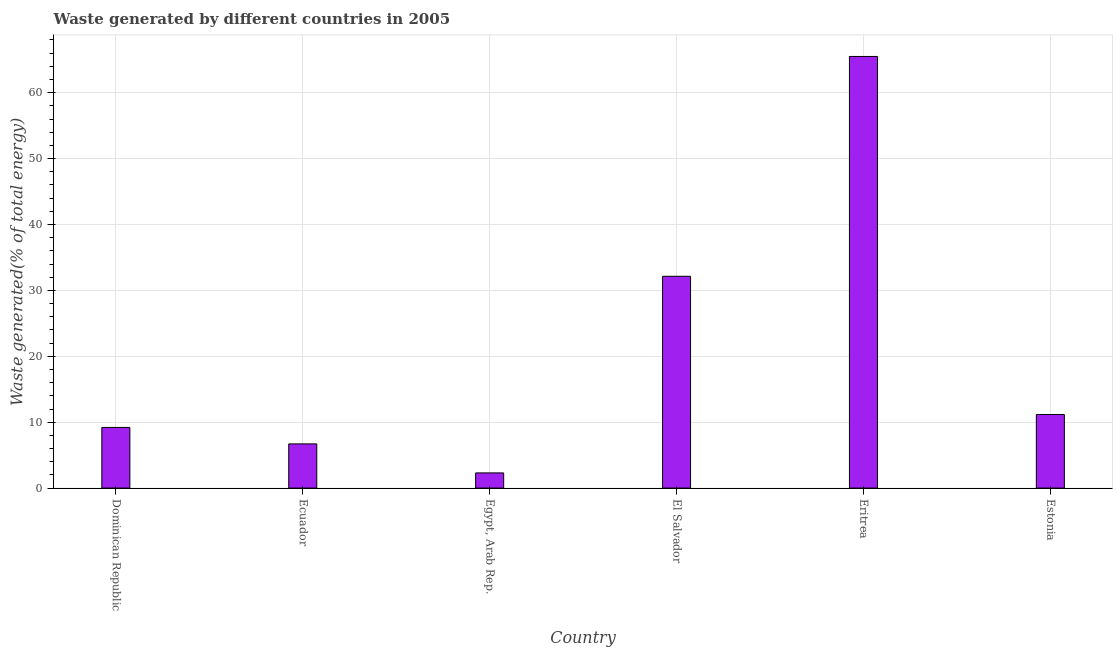Does the graph contain grids?
Provide a succinct answer. Yes. What is the title of the graph?
Keep it short and to the point. Waste generated by different countries in 2005. What is the label or title of the X-axis?
Provide a succinct answer. Country. What is the label or title of the Y-axis?
Your answer should be very brief. Waste generated(% of total energy). What is the amount of waste generated in El Salvador?
Your response must be concise. 32.14. Across all countries, what is the maximum amount of waste generated?
Your response must be concise. 65.5. Across all countries, what is the minimum amount of waste generated?
Provide a short and direct response. 2.3. In which country was the amount of waste generated maximum?
Your answer should be compact. Eritrea. In which country was the amount of waste generated minimum?
Ensure brevity in your answer.  Egypt, Arab Rep. What is the sum of the amount of waste generated?
Your answer should be compact. 127.02. What is the difference between the amount of waste generated in Egypt, Arab Rep. and Estonia?
Offer a very short reply. -8.86. What is the average amount of waste generated per country?
Your response must be concise. 21.17. What is the median amount of waste generated?
Offer a very short reply. 10.19. In how many countries, is the amount of waste generated greater than 10 %?
Your response must be concise. 3. What is the ratio of the amount of waste generated in Ecuador to that in Egypt, Arab Rep.?
Your answer should be very brief. 2.91. What is the difference between the highest and the second highest amount of waste generated?
Offer a very short reply. 33.36. Is the sum of the amount of waste generated in Dominican Republic and Eritrea greater than the maximum amount of waste generated across all countries?
Offer a very short reply. Yes. What is the difference between the highest and the lowest amount of waste generated?
Your answer should be very brief. 63.2. In how many countries, is the amount of waste generated greater than the average amount of waste generated taken over all countries?
Your answer should be compact. 2. How many bars are there?
Your answer should be compact. 6. How many countries are there in the graph?
Offer a very short reply. 6. What is the difference between two consecutive major ticks on the Y-axis?
Offer a very short reply. 10. Are the values on the major ticks of Y-axis written in scientific E-notation?
Provide a succinct answer. No. What is the Waste generated(% of total energy) in Dominican Republic?
Give a very brief answer. 9.21. What is the Waste generated(% of total energy) in Ecuador?
Make the answer very short. 6.71. What is the Waste generated(% of total energy) in Egypt, Arab Rep.?
Give a very brief answer. 2.3. What is the Waste generated(% of total energy) of El Salvador?
Provide a short and direct response. 32.14. What is the Waste generated(% of total energy) of Eritrea?
Offer a very short reply. 65.5. What is the Waste generated(% of total energy) in Estonia?
Provide a short and direct response. 11.17. What is the difference between the Waste generated(% of total energy) in Dominican Republic and Ecuador?
Make the answer very short. 2.5. What is the difference between the Waste generated(% of total energy) in Dominican Republic and Egypt, Arab Rep.?
Make the answer very short. 6.9. What is the difference between the Waste generated(% of total energy) in Dominican Republic and El Salvador?
Give a very brief answer. -22.94. What is the difference between the Waste generated(% of total energy) in Dominican Republic and Eritrea?
Make the answer very short. -56.29. What is the difference between the Waste generated(% of total energy) in Dominican Republic and Estonia?
Your response must be concise. -1.96. What is the difference between the Waste generated(% of total energy) in Ecuador and Egypt, Arab Rep.?
Provide a succinct answer. 4.4. What is the difference between the Waste generated(% of total energy) in Ecuador and El Salvador?
Provide a short and direct response. -25.44. What is the difference between the Waste generated(% of total energy) in Ecuador and Eritrea?
Provide a succinct answer. -58.79. What is the difference between the Waste generated(% of total energy) in Ecuador and Estonia?
Keep it short and to the point. -4.46. What is the difference between the Waste generated(% of total energy) in Egypt, Arab Rep. and El Salvador?
Provide a short and direct response. -29.84. What is the difference between the Waste generated(% of total energy) in Egypt, Arab Rep. and Eritrea?
Keep it short and to the point. -63.2. What is the difference between the Waste generated(% of total energy) in Egypt, Arab Rep. and Estonia?
Keep it short and to the point. -8.86. What is the difference between the Waste generated(% of total energy) in El Salvador and Eritrea?
Offer a very short reply. -33.36. What is the difference between the Waste generated(% of total energy) in El Salvador and Estonia?
Keep it short and to the point. 20.97. What is the difference between the Waste generated(% of total energy) in Eritrea and Estonia?
Keep it short and to the point. 54.33. What is the ratio of the Waste generated(% of total energy) in Dominican Republic to that in Ecuador?
Keep it short and to the point. 1.37. What is the ratio of the Waste generated(% of total energy) in Dominican Republic to that in Egypt, Arab Rep.?
Provide a short and direct response. 4. What is the ratio of the Waste generated(% of total energy) in Dominican Republic to that in El Salvador?
Ensure brevity in your answer.  0.29. What is the ratio of the Waste generated(% of total energy) in Dominican Republic to that in Eritrea?
Your answer should be compact. 0.14. What is the ratio of the Waste generated(% of total energy) in Dominican Republic to that in Estonia?
Your answer should be compact. 0.82. What is the ratio of the Waste generated(% of total energy) in Ecuador to that in Egypt, Arab Rep.?
Ensure brevity in your answer.  2.91. What is the ratio of the Waste generated(% of total energy) in Ecuador to that in El Salvador?
Make the answer very short. 0.21. What is the ratio of the Waste generated(% of total energy) in Ecuador to that in Eritrea?
Make the answer very short. 0.1. What is the ratio of the Waste generated(% of total energy) in Ecuador to that in Estonia?
Keep it short and to the point. 0.6. What is the ratio of the Waste generated(% of total energy) in Egypt, Arab Rep. to that in El Salvador?
Your answer should be very brief. 0.07. What is the ratio of the Waste generated(% of total energy) in Egypt, Arab Rep. to that in Eritrea?
Keep it short and to the point. 0.04. What is the ratio of the Waste generated(% of total energy) in Egypt, Arab Rep. to that in Estonia?
Give a very brief answer. 0.21. What is the ratio of the Waste generated(% of total energy) in El Salvador to that in Eritrea?
Offer a very short reply. 0.49. What is the ratio of the Waste generated(% of total energy) in El Salvador to that in Estonia?
Make the answer very short. 2.88. What is the ratio of the Waste generated(% of total energy) in Eritrea to that in Estonia?
Your answer should be very brief. 5.87. 